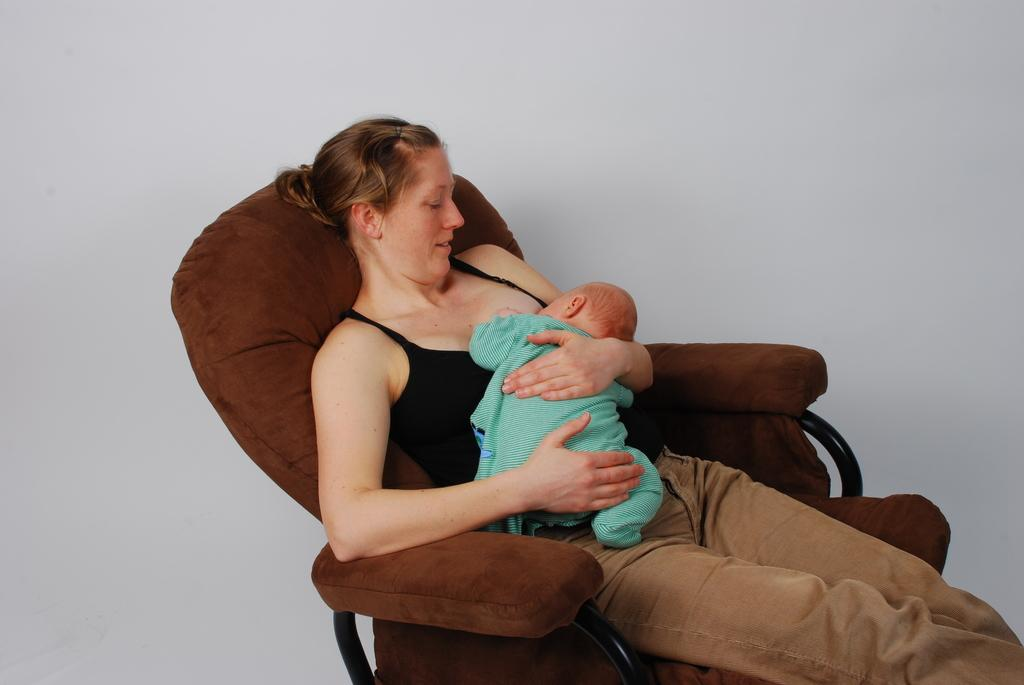Who is the main subject in the image? There is a woman in the image. What is the woman doing in the image? The woman is holding a baby. Where is the woman sitting in the image? The woman is sitting on a chair. What can be seen behind the chair in the image? There is a white background behind the chair. What type of pear is sitting on the beam in the image? There is no pear or beam present in the image. 